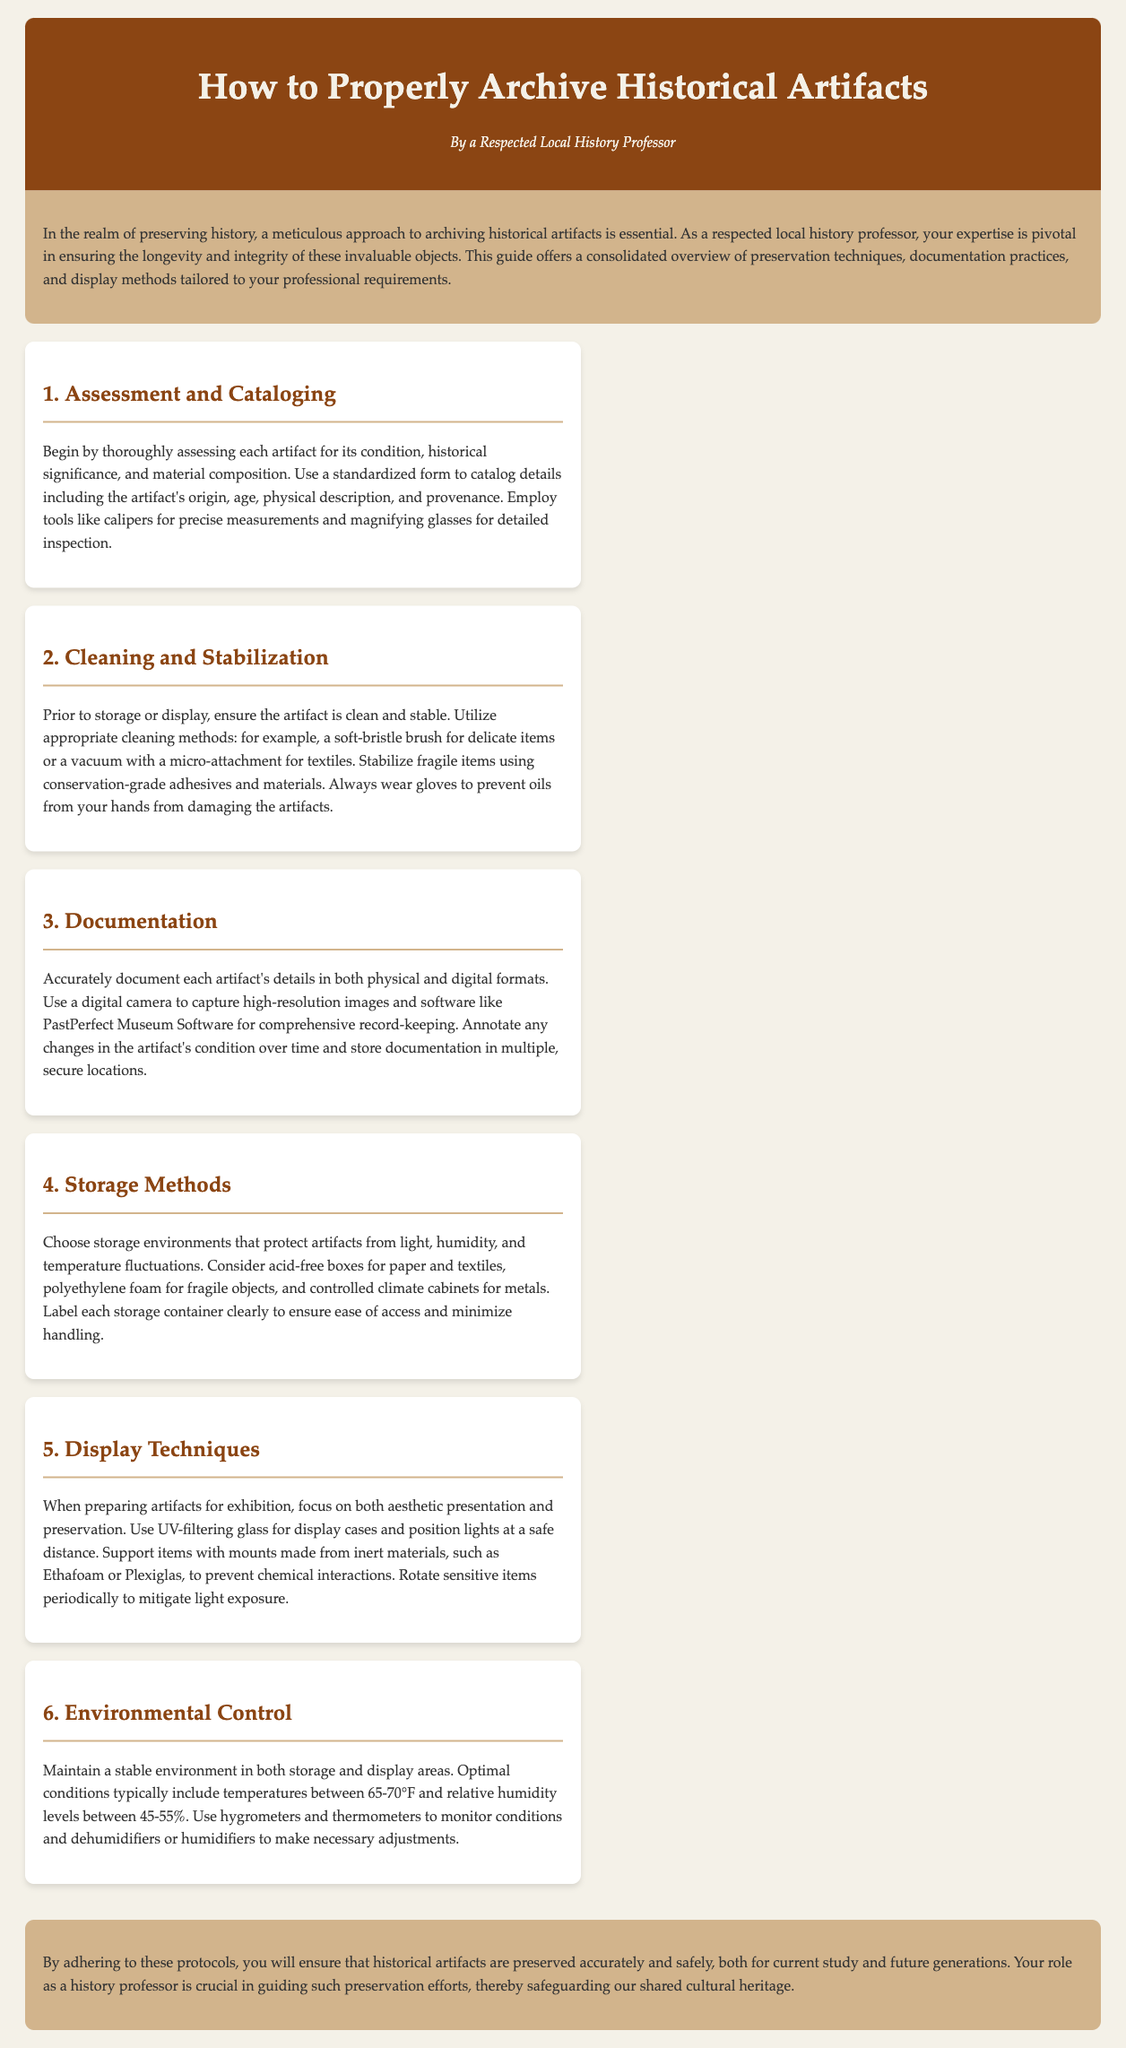What is the title of the guide? The title of the guide is presented prominently at the top of the document.
Answer: How to Properly Archive Historical Artifacts Who is the author of the guide? The author is mentioned below the title, indicating their expertise and role.
Answer: A Respected Local History Professor What is the first step in the archiving process? The first step is outlined in the series of steps provided in the document.
Answer: Assessment and Cataloging What is the recommended temperature for artifact storage? The optimal temperature for storage is given in the environmental control section.
Answer: 65-70°F What cleaning tool is suggested for delicate items? The guide specifies cleaning methods suitable for different types of artifacts.
Answer: Soft-bristle brush Which software is recommended for record-keeping? The guide suggests a specific software tool for documentation purposes.
Answer: PastPerfect Museum Software What material should be used for display mounts? The document recommends a material that is inert for preservation during display.
Answer: Ethafoam What is a primary aim of the archiving guide? The conclusion summarizes the overall purpose of the guide.
Answer: Preserve historical artifacts safely 